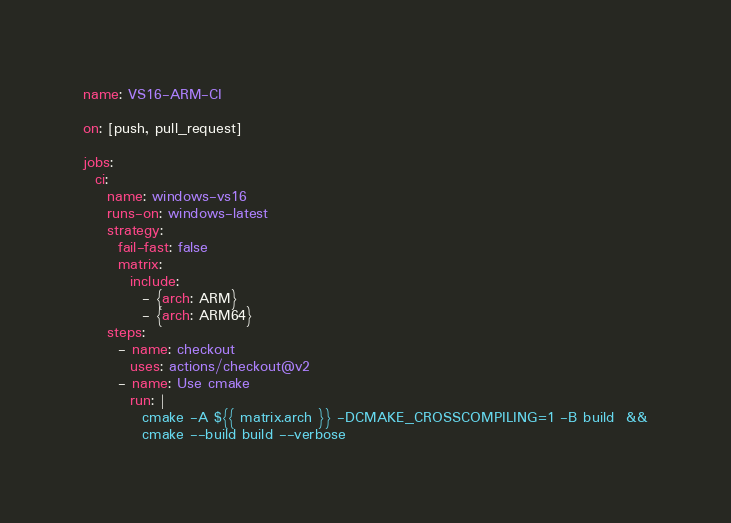<code> <loc_0><loc_0><loc_500><loc_500><_YAML_>name: VS16-ARM-CI

on: [push, pull_request]

jobs:
  ci:
    name: windows-vs16
    runs-on: windows-latest
    strategy:
      fail-fast: false
      matrix:
        include:
          - {arch: ARM}
          - {arch: ARM64}
    steps:
      - name: checkout
        uses: actions/checkout@v2
      - name: Use cmake
        run: |
          cmake -A ${{ matrix.arch }} -DCMAKE_CROSSCOMPILING=1 -B build  &&
          cmake --build build --verbose
</code> 